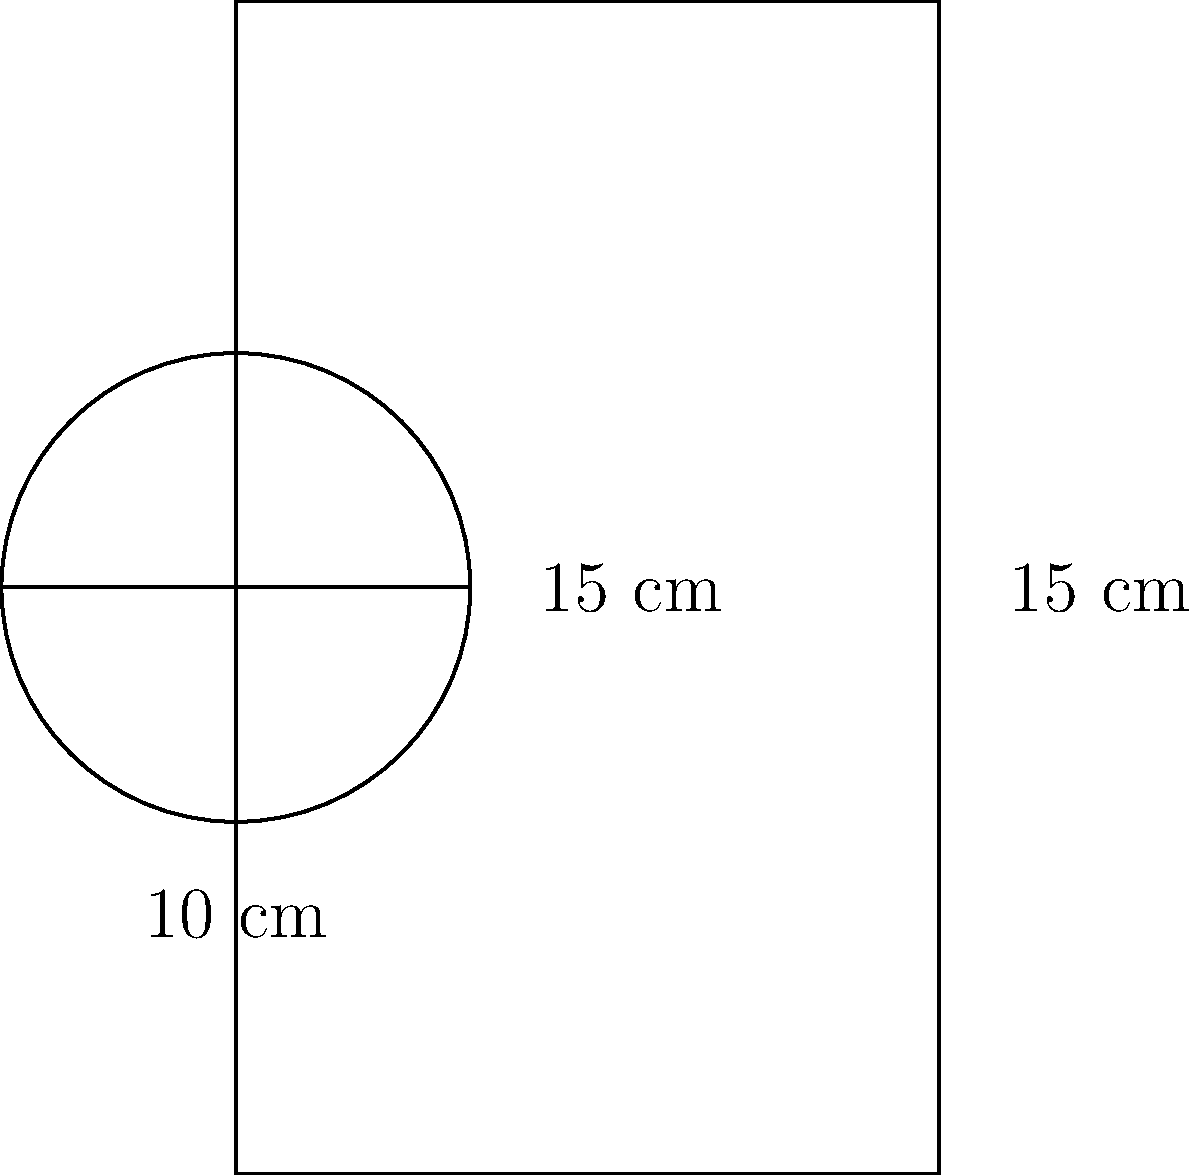For your study group's end-of-year celebration, you've decided to make a big batch of your famous punch. You found a cylindrical container perfect for the occasion. If the container has a radius of 10 cm and a height of 15 cm, what volume of punch (in liters) can you prepare for your friends? Let's approach this step-by-step:

1) The formula for the volume of a cylinder is:
   $$V = \pi r^2 h$$
   where $r$ is the radius and $h$ is the height.

2) We're given:
   Radius ($r$) = 10 cm
   Height ($h$) = 15 cm

3) Let's substitute these values into our formula:
   $$V = \pi (10 \text{ cm})^2 (15 \text{ cm})$$

4) Simplify:
   $$V = \pi (100 \text{ cm}^2) (15 \text{ cm})$$
   $$V = 1500\pi \text{ cm}^3$$

5) Calculate:
   $$V \approx 4712.39 \text{ cm}^3$$

6) Convert cubic centimeters to liters:
   1 liter = 1000 cm³
   $$4712.39 \text{ cm}^3 \div 1000 \text{ cm}^3/L \approx 4.71 \text{ L}$$

Therefore, you can prepare approximately 4.71 liters of punch for your study group celebration.
Answer: 4.71 L 